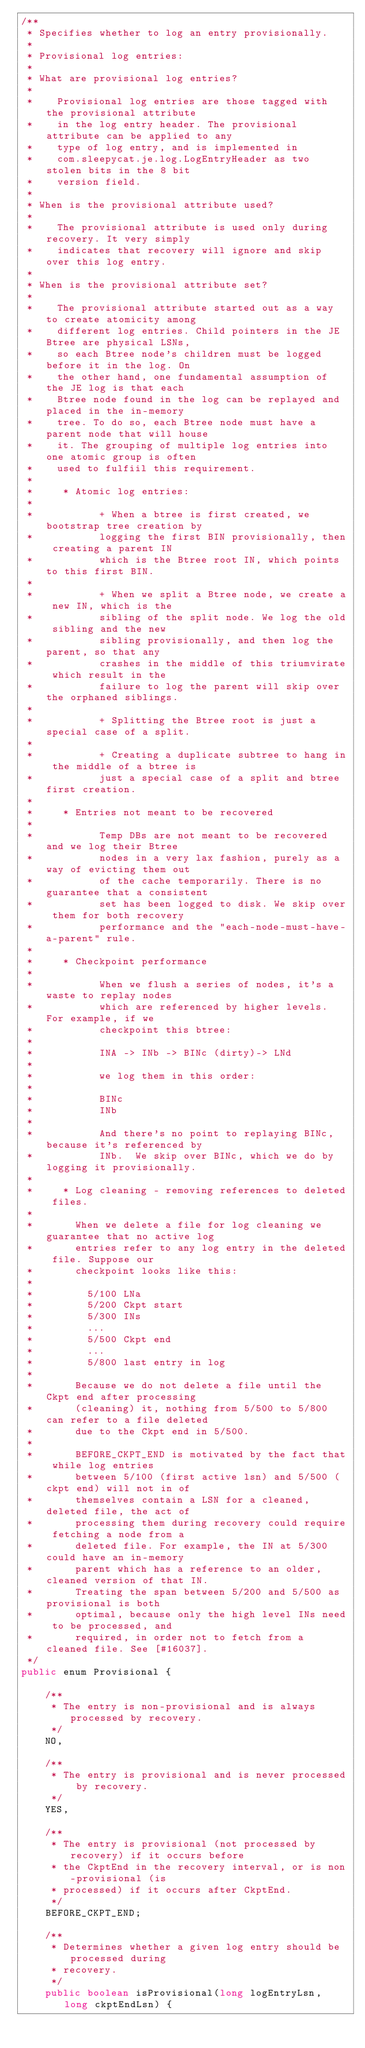Convert code to text. <code><loc_0><loc_0><loc_500><loc_500><_Java_>/**
 * Specifies whether to log an entry provisionally.
 *
 * Provisional log entries:
 * 
 * What are provisional log entries?
 *
 *    Provisional log entries are those tagged with the provisional attribute
 *    in the log entry header. The provisional attribute can be applied to any
 *    type of log entry, and is implemented in
 *    com.sleepycat.je.log.LogEntryHeader as two stolen bits in the 8 bit
 *    version field.
 *
 * When is the provisional attribute used?
 * 
 *    The provisional attribute is used only during recovery. It very simply
 *    indicates that recovery will ignore and skip over this log entry.
 * 
 * When is the provisional attribute set?
 * 
 *    The provisional attribute started out as a way to create atomicity among
 *    different log entries. Child pointers in the JE Btree are physical LSNs,
 *    so each Btree node's children must be logged before it in the log. On
 *    the other hand, one fundamental assumption of the JE log is that each
 *    Btree node found in the log can be replayed and placed in the in-memory
 *    tree. To do so, each Btree node must have a parent node that will house
 *    it. The grouping of multiple log entries into one atomic group is often
 *    used to fulfiil this requirement.
 * 
 *     * Atomic log entries:
 *
 *           + When a btree is first created, we bootstrap tree creation by
 *           logging the first BIN provisionally, then creating a parent IN
 *           which is the Btree root IN, which points to this first BIN.
 *
 *           + When we split a Btree node, we create a new IN, which is the
 *           sibling of the split node. We log the old sibling and the new
 *           sibling provisionally, and then log the parent, so that any
 *           crashes in the middle of this triumvirate which result in the
 *           failure to log the parent will skip over the orphaned siblings.
 *
 *           + Splitting the Btree root is just a special case of a split.
 *
 *           + Creating a duplicate subtree to hang in the middle of a btree is
 *           just a special case of a split and btree first creation.
 *
 *     * Entries not meant to be recovered
 *
 *           Temp DBs are not meant to be recovered and we log their Btree
 *           nodes in a very lax fashion, purely as a way of evicting them out
 *           of the cache temporarily. There is no guarantee that a consistent
 *           set has been logged to disk. We skip over them for both recovery
 *           performance and the "each-node-must-have-a-parent" rule.
 *
 *     * Checkpoint performance
 *
 *           When we flush a series of nodes, it's a waste to replay nodes
 *           which are referenced by higher levels. For example, if we
 *           checkpoint this btree:
 * 
 *           INA -> INb -> BINc (dirty)-> LNd
 * 
 *           we log them in this order:
 * 
 *           BINc
 *           INb
 * 
 *           And there's no point to replaying BINc, because it's referenced by
 *           INb.  We skip over BINc, which we do by logging it provisionally.
 * 
 *     * Log cleaning - removing references to deleted files.
 * 
 *       When we delete a file for log cleaning we guarantee that no active log
 *       entries refer to any log entry in the deleted file. Suppose our
 *       checkpoint looks like this:
 * 
 *         5/100 LNa
 *         5/200 Ckpt start
 *         5/300 INs
 *         ...
 *         5/500 Ckpt end
 *         ...
 *         5/800 last entry in log
 * 
 *       Because we do not delete a file until the Ckpt end after processing
 *       (cleaning) it, nothing from 5/500 to 5/800 can refer to a file deleted
 *       due to the Ckpt end in 5/500.
 *
 *       BEFORE_CKPT_END is motivated by the fact that while log entries
 *       between 5/100 (first active lsn) and 5/500 (ckpt end) will not in of
 *       themselves contain a LSN for a cleaned, deleted file, the act of
 *       processing them during recovery could require fetching a node from a
 *       deleted file. For example, the IN at 5/300 could have an in-memory
 *       parent which has a reference to an older, cleaned version of that IN.
 *       Treating the span between 5/200 and 5/500 as provisional is both
 *       optimal, because only the high level INs need to be processed, and
 *       required, in order not to fetch from a cleaned file. See [#16037].
 */
public enum Provisional {

    /**
     * The entry is non-provisional and is always processed by recovery.
     */
    NO,
    
    /**
     * The entry is provisional and is never processed by recovery.
     */
    YES,
    
    /**
     * The entry is provisional (not processed by recovery) if it occurs before
     * the CkptEnd in the recovery interval, or is non-provisional (is
     * processed) if it occurs after CkptEnd.
     */
    BEFORE_CKPT_END;

    /**
     * Determines whether a given log entry should be processed during
     * recovery.
     */
    public boolean isProvisional(long logEntryLsn, long ckptEndLsn) {</code> 